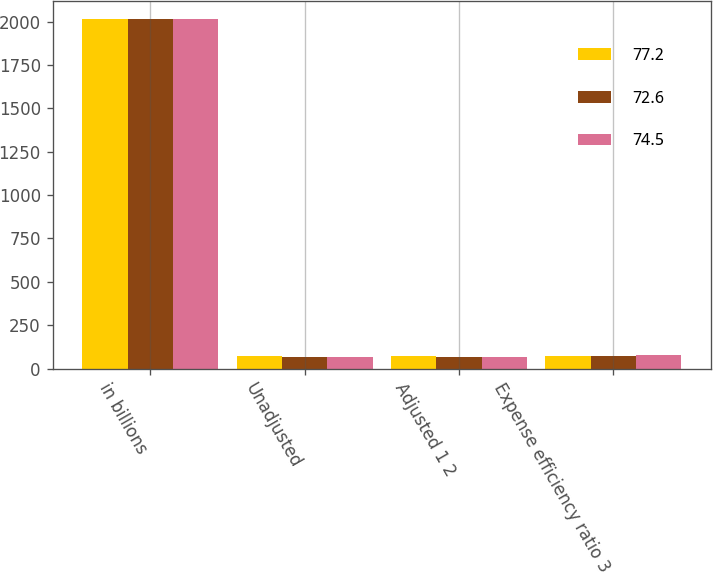Convert chart to OTSL. <chart><loc_0><loc_0><loc_500><loc_500><stacked_bar_chart><ecel><fcel>in billions<fcel>Unadjusted<fcel>Adjusted 1 2<fcel>Expense efficiency ratio 3<nl><fcel>77.2<fcel>2017<fcel>69.8<fcel>69.9<fcel>72.6<nl><fcel>72.6<fcel>2016<fcel>68.9<fcel>68.9<fcel>74.5<nl><fcel>74.5<fcel>2015<fcel>66.9<fcel>67.1<fcel>77.2<nl></chart> 